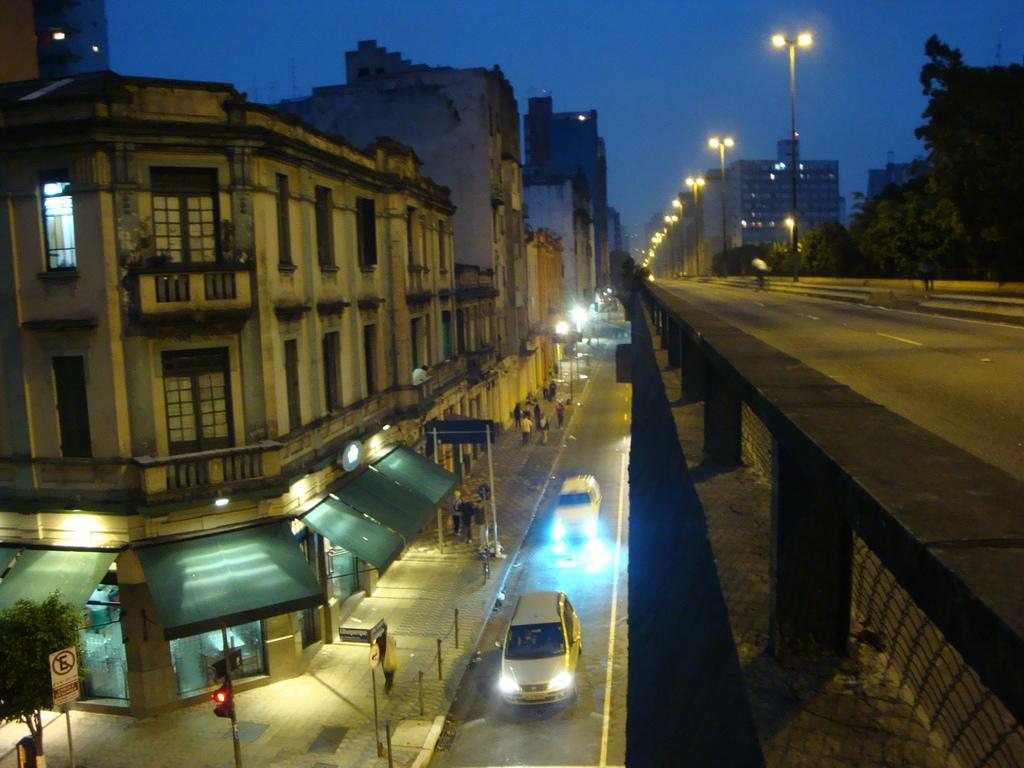Please provide a concise description of this image. This is a picture of the outside of the city, in this picture on the right side and left side there are some buildings, trees and in the center there is one bridge and some cars on the road. And in the center there are some poles and street lights, at the bottom there are some stores and some persons are walking on a footpath. At the top of the image there is sky. 